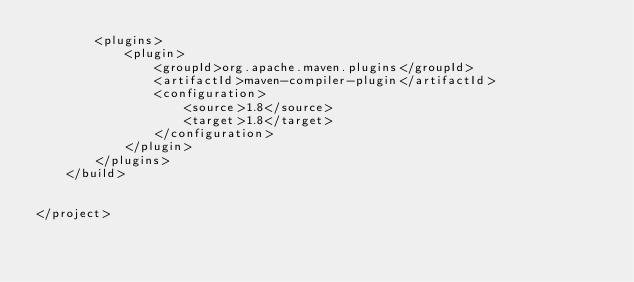<code> <loc_0><loc_0><loc_500><loc_500><_XML_>        <plugins>
            <plugin>
                <groupId>org.apache.maven.plugins</groupId>
                <artifactId>maven-compiler-plugin</artifactId>
                <configuration>
                    <source>1.8</source>
                    <target>1.8</target>
                </configuration>
            </plugin>
        </plugins>
    </build>


</project></code> 